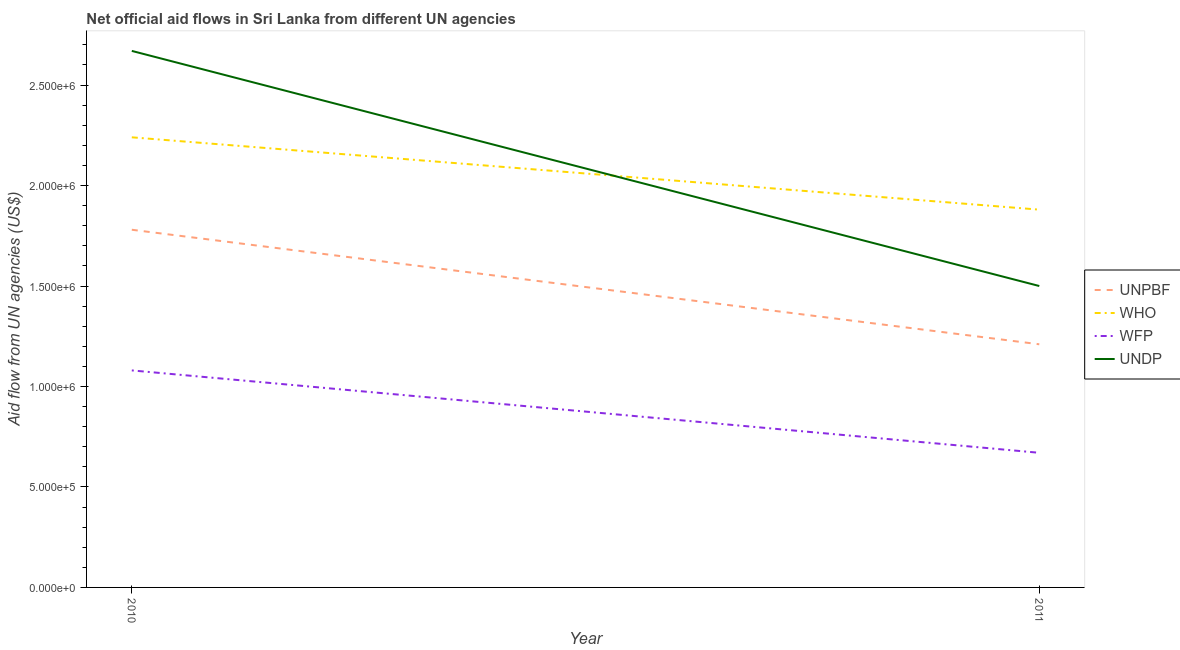Does the line corresponding to amount of aid given by who intersect with the line corresponding to amount of aid given by undp?
Your answer should be compact. Yes. Is the number of lines equal to the number of legend labels?
Give a very brief answer. Yes. What is the amount of aid given by undp in 2010?
Make the answer very short. 2.67e+06. Across all years, what is the maximum amount of aid given by undp?
Your answer should be very brief. 2.67e+06. Across all years, what is the minimum amount of aid given by wfp?
Your answer should be compact. 6.70e+05. In which year was the amount of aid given by wfp maximum?
Keep it short and to the point. 2010. In which year was the amount of aid given by wfp minimum?
Ensure brevity in your answer.  2011. What is the total amount of aid given by who in the graph?
Make the answer very short. 4.12e+06. What is the difference between the amount of aid given by wfp in 2010 and that in 2011?
Make the answer very short. 4.10e+05. What is the difference between the amount of aid given by unpbf in 2011 and the amount of aid given by wfp in 2010?
Provide a succinct answer. 1.30e+05. What is the average amount of aid given by undp per year?
Your answer should be very brief. 2.08e+06. In the year 2011, what is the difference between the amount of aid given by who and amount of aid given by unpbf?
Offer a very short reply. 6.70e+05. In how many years, is the amount of aid given by who greater than 800000 US$?
Provide a short and direct response. 2. What is the ratio of the amount of aid given by unpbf in 2010 to that in 2011?
Offer a very short reply. 1.47. Is it the case that in every year, the sum of the amount of aid given by who and amount of aid given by undp is greater than the sum of amount of aid given by wfp and amount of aid given by unpbf?
Offer a terse response. No. Is the amount of aid given by who strictly less than the amount of aid given by wfp over the years?
Your response must be concise. No. What is the difference between two consecutive major ticks on the Y-axis?
Your answer should be very brief. 5.00e+05. Are the values on the major ticks of Y-axis written in scientific E-notation?
Ensure brevity in your answer.  Yes. Does the graph contain any zero values?
Make the answer very short. No. Where does the legend appear in the graph?
Give a very brief answer. Center right. How are the legend labels stacked?
Ensure brevity in your answer.  Vertical. What is the title of the graph?
Offer a very short reply. Net official aid flows in Sri Lanka from different UN agencies. What is the label or title of the Y-axis?
Your answer should be compact. Aid flow from UN agencies (US$). What is the Aid flow from UN agencies (US$) in UNPBF in 2010?
Make the answer very short. 1.78e+06. What is the Aid flow from UN agencies (US$) of WHO in 2010?
Offer a terse response. 2.24e+06. What is the Aid flow from UN agencies (US$) of WFP in 2010?
Your answer should be very brief. 1.08e+06. What is the Aid flow from UN agencies (US$) in UNDP in 2010?
Make the answer very short. 2.67e+06. What is the Aid flow from UN agencies (US$) of UNPBF in 2011?
Your answer should be very brief. 1.21e+06. What is the Aid flow from UN agencies (US$) in WHO in 2011?
Ensure brevity in your answer.  1.88e+06. What is the Aid flow from UN agencies (US$) of WFP in 2011?
Give a very brief answer. 6.70e+05. What is the Aid flow from UN agencies (US$) in UNDP in 2011?
Keep it short and to the point. 1.50e+06. Across all years, what is the maximum Aid flow from UN agencies (US$) of UNPBF?
Keep it short and to the point. 1.78e+06. Across all years, what is the maximum Aid flow from UN agencies (US$) in WHO?
Give a very brief answer. 2.24e+06. Across all years, what is the maximum Aid flow from UN agencies (US$) in WFP?
Provide a succinct answer. 1.08e+06. Across all years, what is the maximum Aid flow from UN agencies (US$) in UNDP?
Provide a succinct answer. 2.67e+06. Across all years, what is the minimum Aid flow from UN agencies (US$) of UNPBF?
Make the answer very short. 1.21e+06. Across all years, what is the minimum Aid flow from UN agencies (US$) in WHO?
Make the answer very short. 1.88e+06. Across all years, what is the minimum Aid flow from UN agencies (US$) in WFP?
Keep it short and to the point. 6.70e+05. Across all years, what is the minimum Aid flow from UN agencies (US$) of UNDP?
Offer a very short reply. 1.50e+06. What is the total Aid flow from UN agencies (US$) in UNPBF in the graph?
Your answer should be compact. 2.99e+06. What is the total Aid flow from UN agencies (US$) of WHO in the graph?
Offer a terse response. 4.12e+06. What is the total Aid flow from UN agencies (US$) in WFP in the graph?
Your response must be concise. 1.75e+06. What is the total Aid flow from UN agencies (US$) of UNDP in the graph?
Offer a very short reply. 4.17e+06. What is the difference between the Aid flow from UN agencies (US$) in UNPBF in 2010 and that in 2011?
Keep it short and to the point. 5.70e+05. What is the difference between the Aid flow from UN agencies (US$) in UNDP in 2010 and that in 2011?
Your response must be concise. 1.17e+06. What is the difference between the Aid flow from UN agencies (US$) in UNPBF in 2010 and the Aid flow from UN agencies (US$) in WHO in 2011?
Offer a very short reply. -1.00e+05. What is the difference between the Aid flow from UN agencies (US$) of UNPBF in 2010 and the Aid flow from UN agencies (US$) of WFP in 2011?
Your answer should be very brief. 1.11e+06. What is the difference between the Aid flow from UN agencies (US$) in WHO in 2010 and the Aid flow from UN agencies (US$) in WFP in 2011?
Provide a succinct answer. 1.57e+06. What is the difference between the Aid flow from UN agencies (US$) of WHO in 2010 and the Aid flow from UN agencies (US$) of UNDP in 2011?
Offer a very short reply. 7.40e+05. What is the difference between the Aid flow from UN agencies (US$) in WFP in 2010 and the Aid flow from UN agencies (US$) in UNDP in 2011?
Your answer should be very brief. -4.20e+05. What is the average Aid flow from UN agencies (US$) in UNPBF per year?
Ensure brevity in your answer.  1.50e+06. What is the average Aid flow from UN agencies (US$) in WHO per year?
Your response must be concise. 2.06e+06. What is the average Aid flow from UN agencies (US$) of WFP per year?
Provide a short and direct response. 8.75e+05. What is the average Aid flow from UN agencies (US$) in UNDP per year?
Keep it short and to the point. 2.08e+06. In the year 2010, what is the difference between the Aid flow from UN agencies (US$) in UNPBF and Aid flow from UN agencies (US$) in WHO?
Your answer should be very brief. -4.60e+05. In the year 2010, what is the difference between the Aid flow from UN agencies (US$) in UNPBF and Aid flow from UN agencies (US$) in WFP?
Your answer should be very brief. 7.00e+05. In the year 2010, what is the difference between the Aid flow from UN agencies (US$) of UNPBF and Aid flow from UN agencies (US$) of UNDP?
Ensure brevity in your answer.  -8.90e+05. In the year 2010, what is the difference between the Aid flow from UN agencies (US$) in WHO and Aid flow from UN agencies (US$) in WFP?
Your answer should be compact. 1.16e+06. In the year 2010, what is the difference between the Aid flow from UN agencies (US$) in WHO and Aid flow from UN agencies (US$) in UNDP?
Ensure brevity in your answer.  -4.30e+05. In the year 2010, what is the difference between the Aid flow from UN agencies (US$) of WFP and Aid flow from UN agencies (US$) of UNDP?
Your answer should be very brief. -1.59e+06. In the year 2011, what is the difference between the Aid flow from UN agencies (US$) of UNPBF and Aid flow from UN agencies (US$) of WHO?
Offer a very short reply. -6.70e+05. In the year 2011, what is the difference between the Aid flow from UN agencies (US$) of UNPBF and Aid flow from UN agencies (US$) of WFP?
Offer a terse response. 5.40e+05. In the year 2011, what is the difference between the Aid flow from UN agencies (US$) of UNPBF and Aid flow from UN agencies (US$) of UNDP?
Your answer should be very brief. -2.90e+05. In the year 2011, what is the difference between the Aid flow from UN agencies (US$) in WHO and Aid flow from UN agencies (US$) in WFP?
Provide a short and direct response. 1.21e+06. In the year 2011, what is the difference between the Aid flow from UN agencies (US$) of WFP and Aid flow from UN agencies (US$) of UNDP?
Provide a succinct answer. -8.30e+05. What is the ratio of the Aid flow from UN agencies (US$) of UNPBF in 2010 to that in 2011?
Make the answer very short. 1.47. What is the ratio of the Aid flow from UN agencies (US$) in WHO in 2010 to that in 2011?
Your answer should be very brief. 1.19. What is the ratio of the Aid flow from UN agencies (US$) of WFP in 2010 to that in 2011?
Provide a short and direct response. 1.61. What is the ratio of the Aid flow from UN agencies (US$) in UNDP in 2010 to that in 2011?
Make the answer very short. 1.78. What is the difference between the highest and the second highest Aid flow from UN agencies (US$) in UNPBF?
Your answer should be very brief. 5.70e+05. What is the difference between the highest and the second highest Aid flow from UN agencies (US$) in WFP?
Your response must be concise. 4.10e+05. What is the difference between the highest and the second highest Aid flow from UN agencies (US$) of UNDP?
Provide a succinct answer. 1.17e+06. What is the difference between the highest and the lowest Aid flow from UN agencies (US$) of UNPBF?
Provide a succinct answer. 5.70e+05. What is the difference between the highest and the lowest Aid flow from UN agencies (US$) of WHO?
Offer a very short reply. 3.60e+05. What is the difference between the highest and the lowest Aid flow from UN agencies (US$) of UNDP?
Your answer should be very brief. 1.17e+06. 